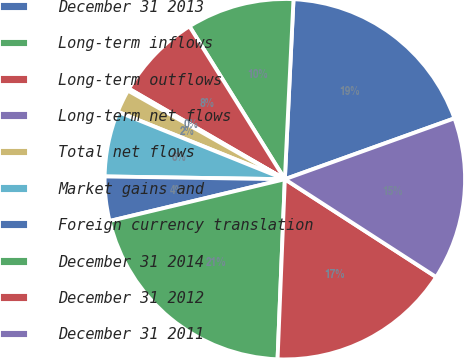<chart> <loc_0><loc_0><loc_500><loc_500><pie_chart><fcel>December 31 2013<fcel>Long-term inflows<fcel>Long-term outflows<fcel>Long-term net flows<fcel>Total net flows<fcel>Market gains and<fcel>Foreign currency translation<fcel>December 31 2014<fcel>December 31 2012<fcel>December 31 2011<nl><fcel>18.75%<fcel>9.64%<fcel>7.75%<fcel>0.19%<fcel>2.08%<fcel>5.86%<fcel>3.97%<fcel>20.63%<fcel>16.51%<fcel>14.62%<nl></chart> 